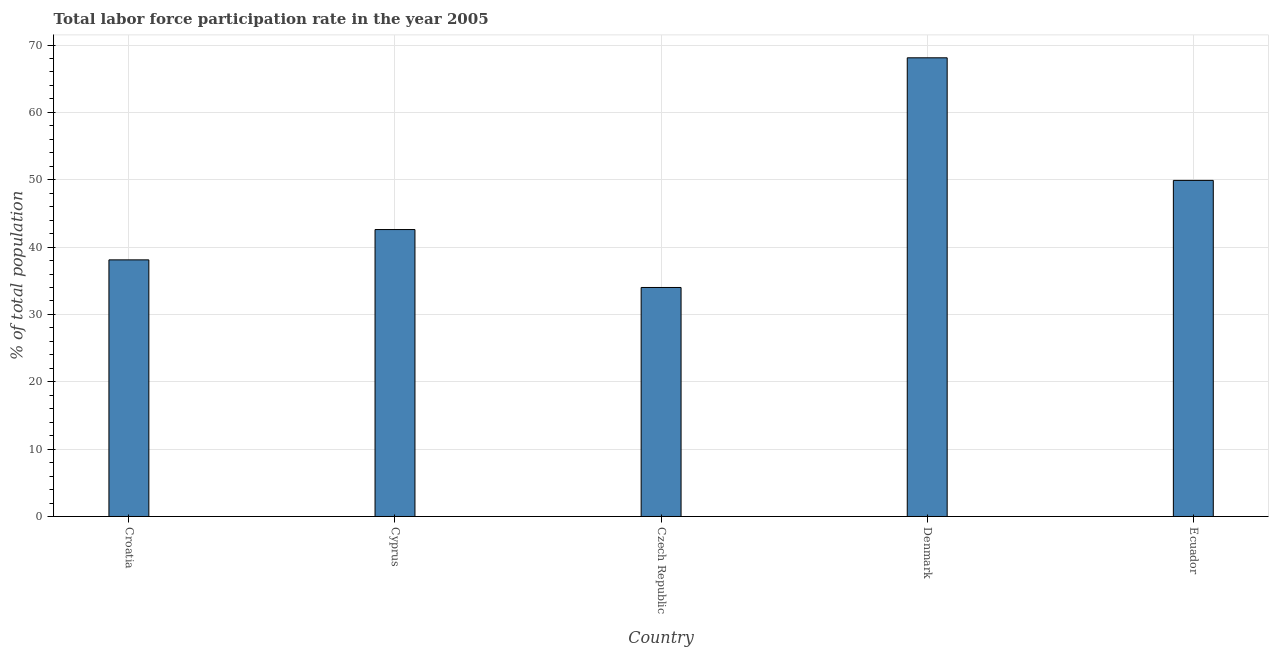What is the title of the graph?
Offer a very short reply. Total labor force participation rate in the year 2005. What is the label or title of the X-axis?
Your answer should be very brief. Country. What is the label or title of the Y-axis?
Provide a succinct answer. % of total population. What is the total labor force participation rate in Croatia?
Provide a succinct answer. 38.1. Across all countries, what is the maximum total labor force participation rate?
Make the answer very short. 68.1. In which country was the total labor force participation rate minimum?
Your answer should be very brief. Czech Republic. What is the sum of the total labor force participation rate?
Your response must be concise. 232.7. What is the difference between the total labor force participation rate in Czech Republic and Ecuador?
Offer a terse response. -15.9. What is the average total labor force participation rate per country?
Offer a very short reply. 46.54. What is the median total labor force participation rate?
Provide a short and direct response. 42.6. What is the ratio of the total labor force participation rate in Croatia to that in Cyprus?
Provide a short and direct response. 0.89. Is the total labor force participation rate in Cyprus less than that in Ecuador?
Ensure brevity in your answer.  Yes. What is the difference between the highest and the lowest total labor force participation rate?
Offer a terse response. 34.1. How many bars are there?
Offer a very short reply. 5. What is the difference between two consecutive major ticks on the Y-axis?
Provide a short and direct response. 10. What is the % of total population of Croatia?
Your response must be concise. 38.1. What is the % of total population of Cyprus?
Your answer should be very brief. 42.6. What is the % of total population of Czech Republic?
Provide a succinct answer. 34. What is the % of total population in Denmark?
Your response must be concise. 68.1. What is the % of total population in Ecuador?
Provide a succinct answer. 49.9. What is the difference between the % of total population in Croatia and Czech Republic?
Give a very brief answer. 4.1. What is the difference between the % of total population in Croatia and Ecuador?
Give a very brief answer. -11.8. What is the difference between the % of total population in Cyprus and Denmark?
Offer a very short reply. -25.5. What is the difference between the % of total population in Czech Republic and Denmark?
Your answer should be very brief. -34.1. What is the difference between the % of total population in Czech Republic and Ecuador?
Make the answer very short. -15.9. What is the ratio of the % of total population in Croatia to that in Cyprus?
Ensure brevity in your answer.  0.89. What is the ratio of the % of total population in Croatia to that in Czech Republic?
Provide a succinct answer. 1.12. What is the ratio of the % of total population in Croatia to that in Denmark?
Keep it short and to the point. 0.56. What is the ratio of the % of total population in Croatia to that in Ecuador?
Offer a very short reply. 0.76. What is the ratio of the % of total population in Cyprus to that in Czech Republic?
Your answer should be compact. 1.25. What is the ratio of the % of total population in Cyprus to that in Denmark?
Provide a short and direct response. 0.63. What is the ratio of the % of total population in Cyprus to that in Ecuador?
Provide a short and direct response. 0.85. What is the ratio of the % of total population in Czech Republic to that in Denmark?
Ensure brevity in your answer.  0.5. What is the ratio of the % of total population in Czech Republic to that in Ecuador?
Offer a terse response. 0.68. What is the ratio of the % of total population in Denmark to that in Ecuador?
Offer a very short reply. 1.36. 